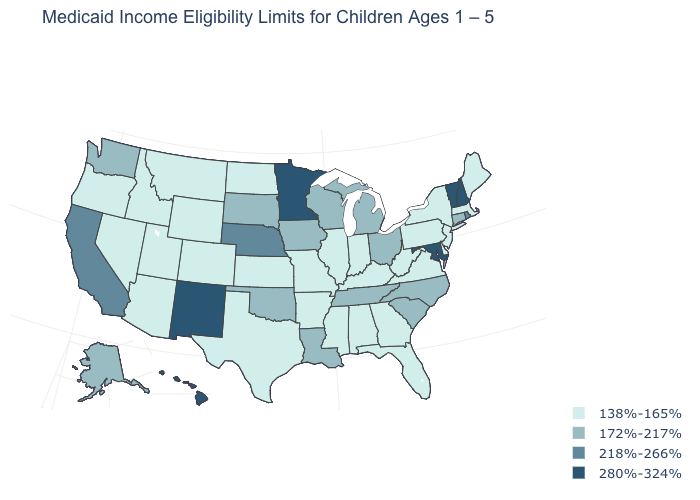Among the states that border New Mexico , which have the lowest value?
Keep it brief. Arizona, Colorado, Texas, Utah. What is the value of Massachusetts?
Be succinct. 138%-165%. Among the states that border Vermont , does Massachusetts have the highest value?
Write a very short answer. No. What is the highest value in the West ?
Concise answer only. 280%-324%. What is the value of Washington?
Write a very short answer. 172%-217%. Does Maryland have the highest value in the South?
Quick response, please. Yes. What is the value of New Jersey?
Give a very brief answer. 138%-165%. Does Wyoming have the highest value in the USA?
Answer briefly. No. What is the highest value in the South ?
Write a very short answer. 280%-324%. What is the value of Virginia?
Give a very brief answer. 138%-165%. Among the states that border West Virginia , which have the highest value?
Keep it brief. Maryland. Name the states that have a value in the range 280%-324%?
Quick response, please. Hawaii, Maryland, Minnesota, New Hampshire, New Mexico, Vermont. Among the states that border New York , does Connecticut have the highest value?
Write a very short answer. No. Does Hawaii have the highest value in the USA?
Give a very brief answer. Yes. What is the lowest value in the MidWest?
Quick response, please. 138%-165%. 